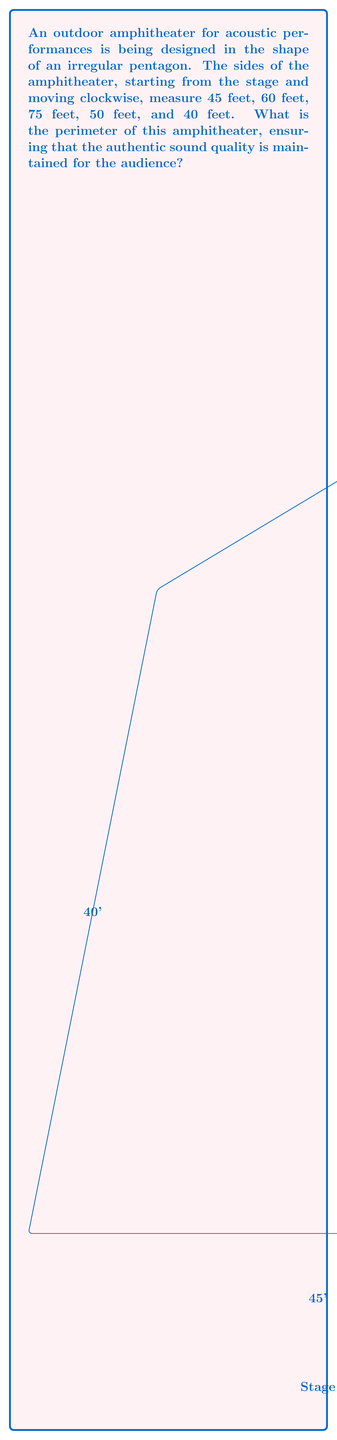Show me your answer to this math problem. To find the perimeter of the irregularly shaped amphitheater, we need to sum up the lengths of all its sides. This approach ensures we account for the entire boundary of the performance space, which is crucial for maintaining authentic sound quality throughout the venue.

Let's add up the lengths of each side:

1. Stage side: 45 feet
2. Right side: 60 feet
3. Back side: 75 feet
4. Left side: 50 feet
5. Front side (opposite to stage): 40 feet

Using the formula for perimeter of a polygon:

$$P = s_1 + s_2 + s_3 + s_4 + s_5$$

Where $s_1, s_2, s_3, s_4,$ and $s_5$ represent the lengths of each side.

Substituting the values:

$$P = 45 + 60 + 75 + 50 + 40$$

$$P = 270 \text{ feet}$$

This total perimeter ensures that the amphitheater's shape accommodates the acoustic requirements for authentic sound production and audience experience.
Answer: 270 feet 